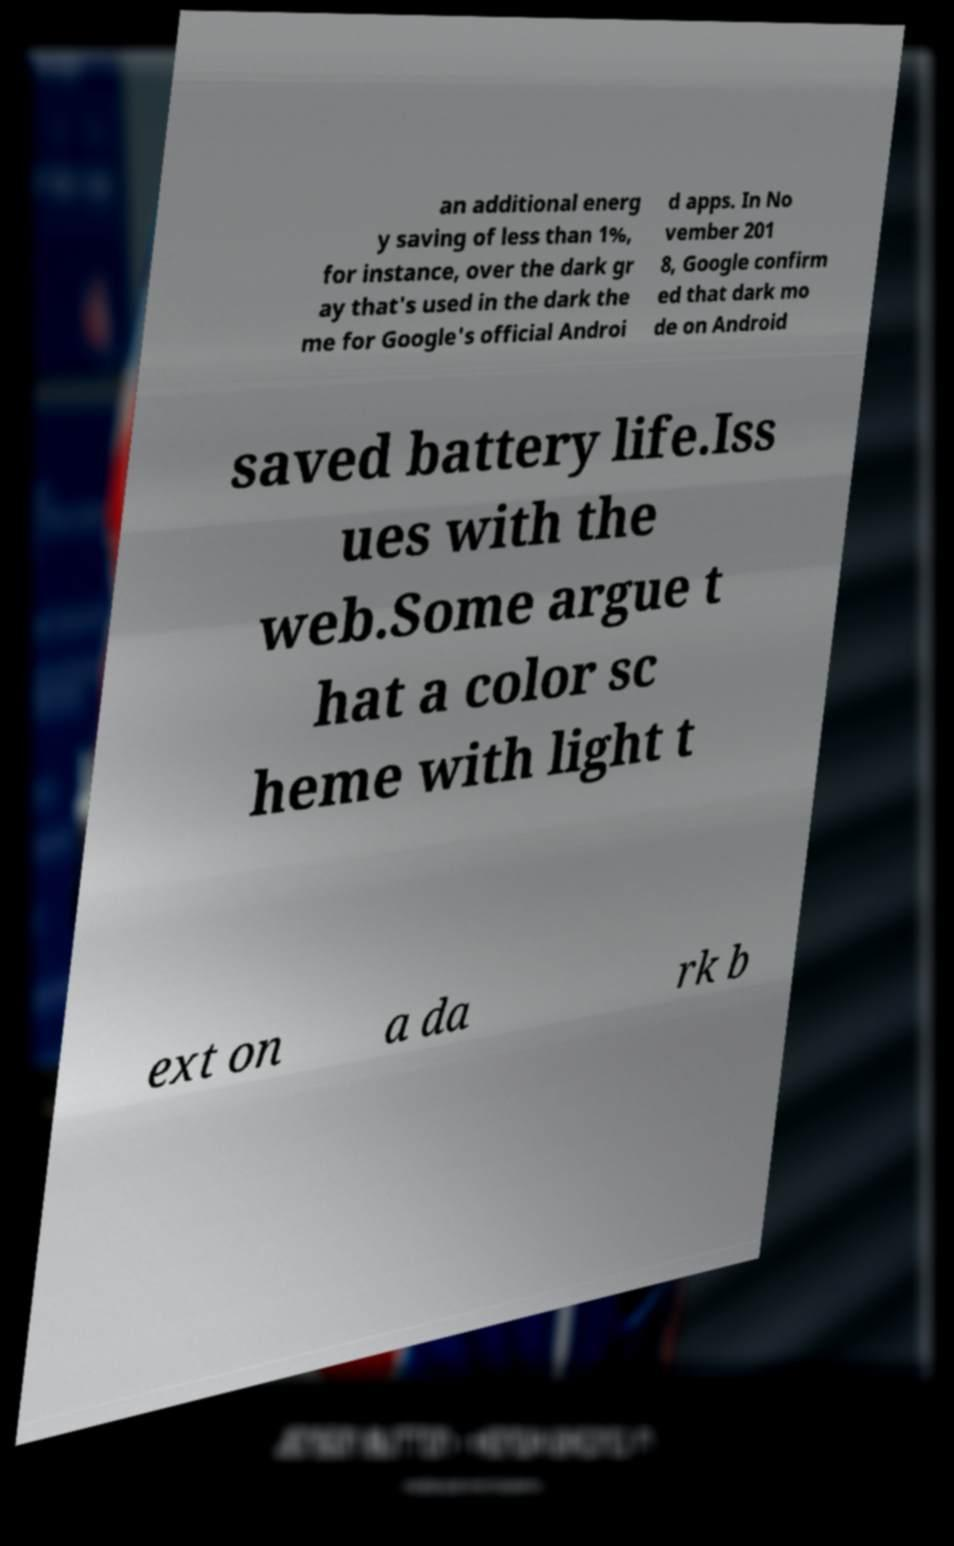Can you accurately transcribe the text from the provided image for me? an additional energ y saving of less than 1%, for instance, over the dark gr ay that's used in the dark the me for Google's official Androi d apps. In No vember 201 8, Google confirm ed that dark mo de on Android saved battery life.Iss ues with the web.Some argue t hat a color sc heme with light t ext on a da rk b 